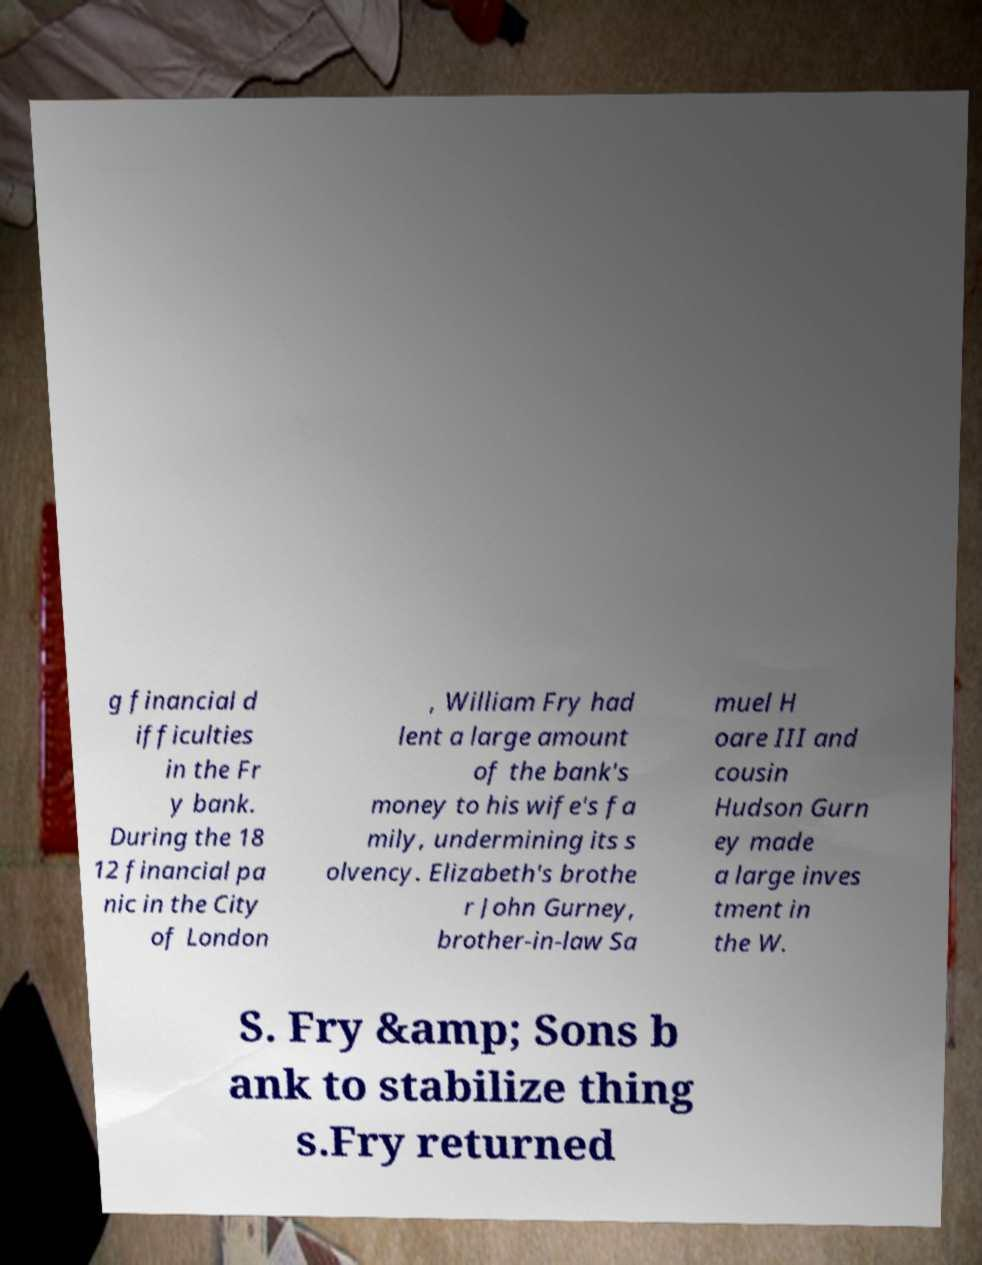For documentation purposes, I need the text within this image transcribed. Could you provide that? g financial d ifficulties in the Fr y bank. During the 18 12 financial pa nic in the City of London , William Fry had lent a large amount of the bank's money to his wife's fa mily, undermining its s olvency. Elizabeth's brothe r John Gurney, brother-in-law Sa muel H oare III and cousin Hudson Gurn ey made a large inves tment in the W. S. Fry &amp; Sons b ank to stabilize thing s.Fry returned 